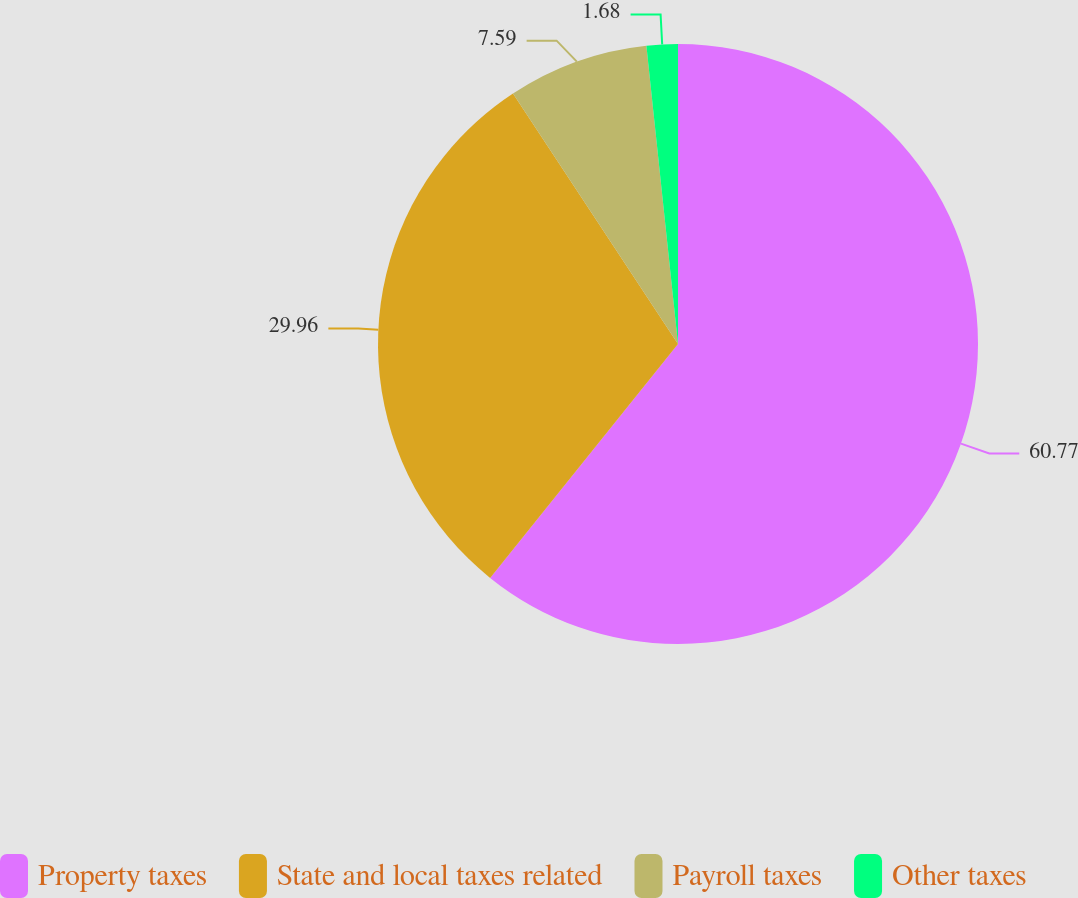Convert chart to OTSL. <chart><loc_0><loc_0><loc_500><loc_500><pie_chart><fcel>Property taxes<fcel>State and local taxes related<fcel>Payroll taxes<fcel>Other taxes<nl><fcel>60.77%<fcel>29.96%<fcel>7.59%<fcel>1.68%<nl></chart> 